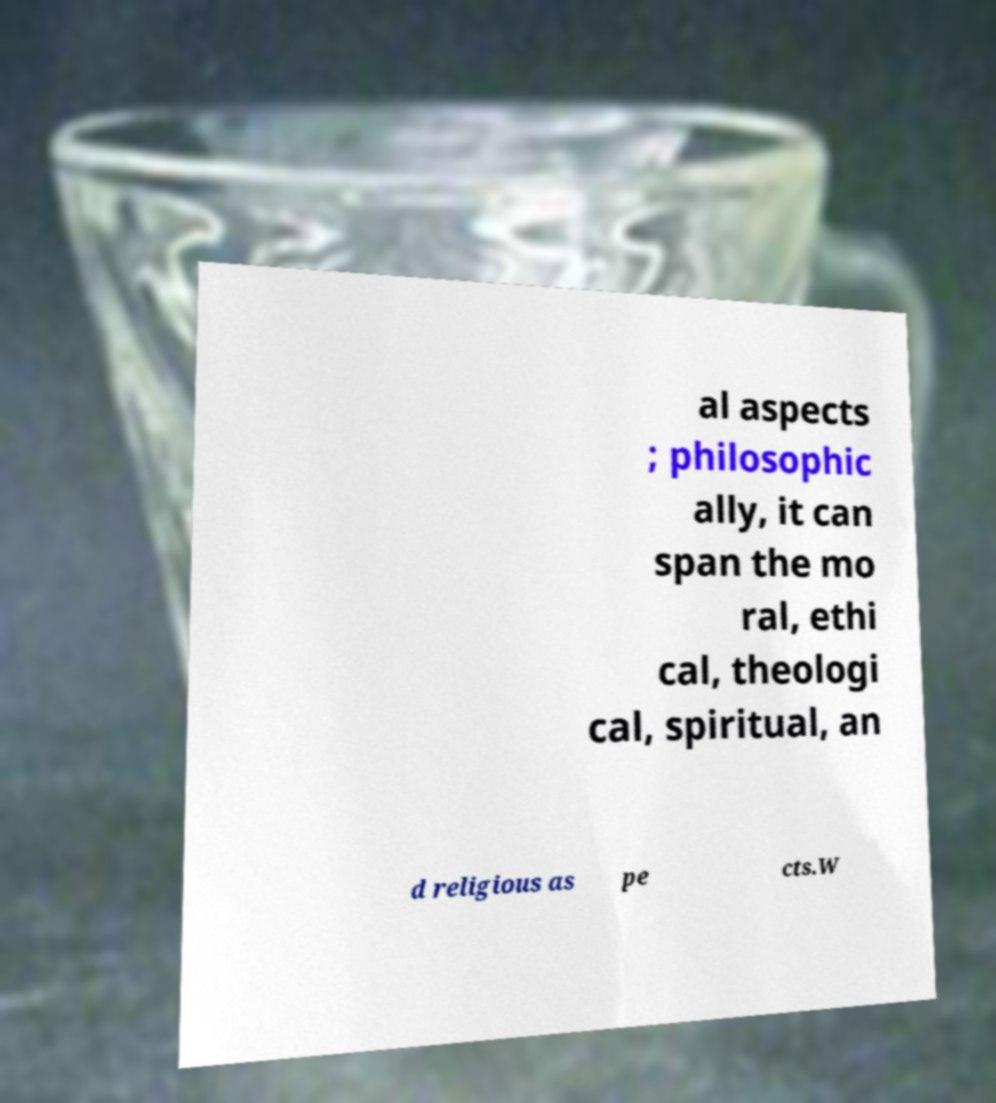For documentation purposes, I need the text within this image transcribed. Could you provide that? al aspects ; philosophic ally, it can span the mo ral, ethi cal, theologi cal, spiritual, an d religious as pe cts.W 